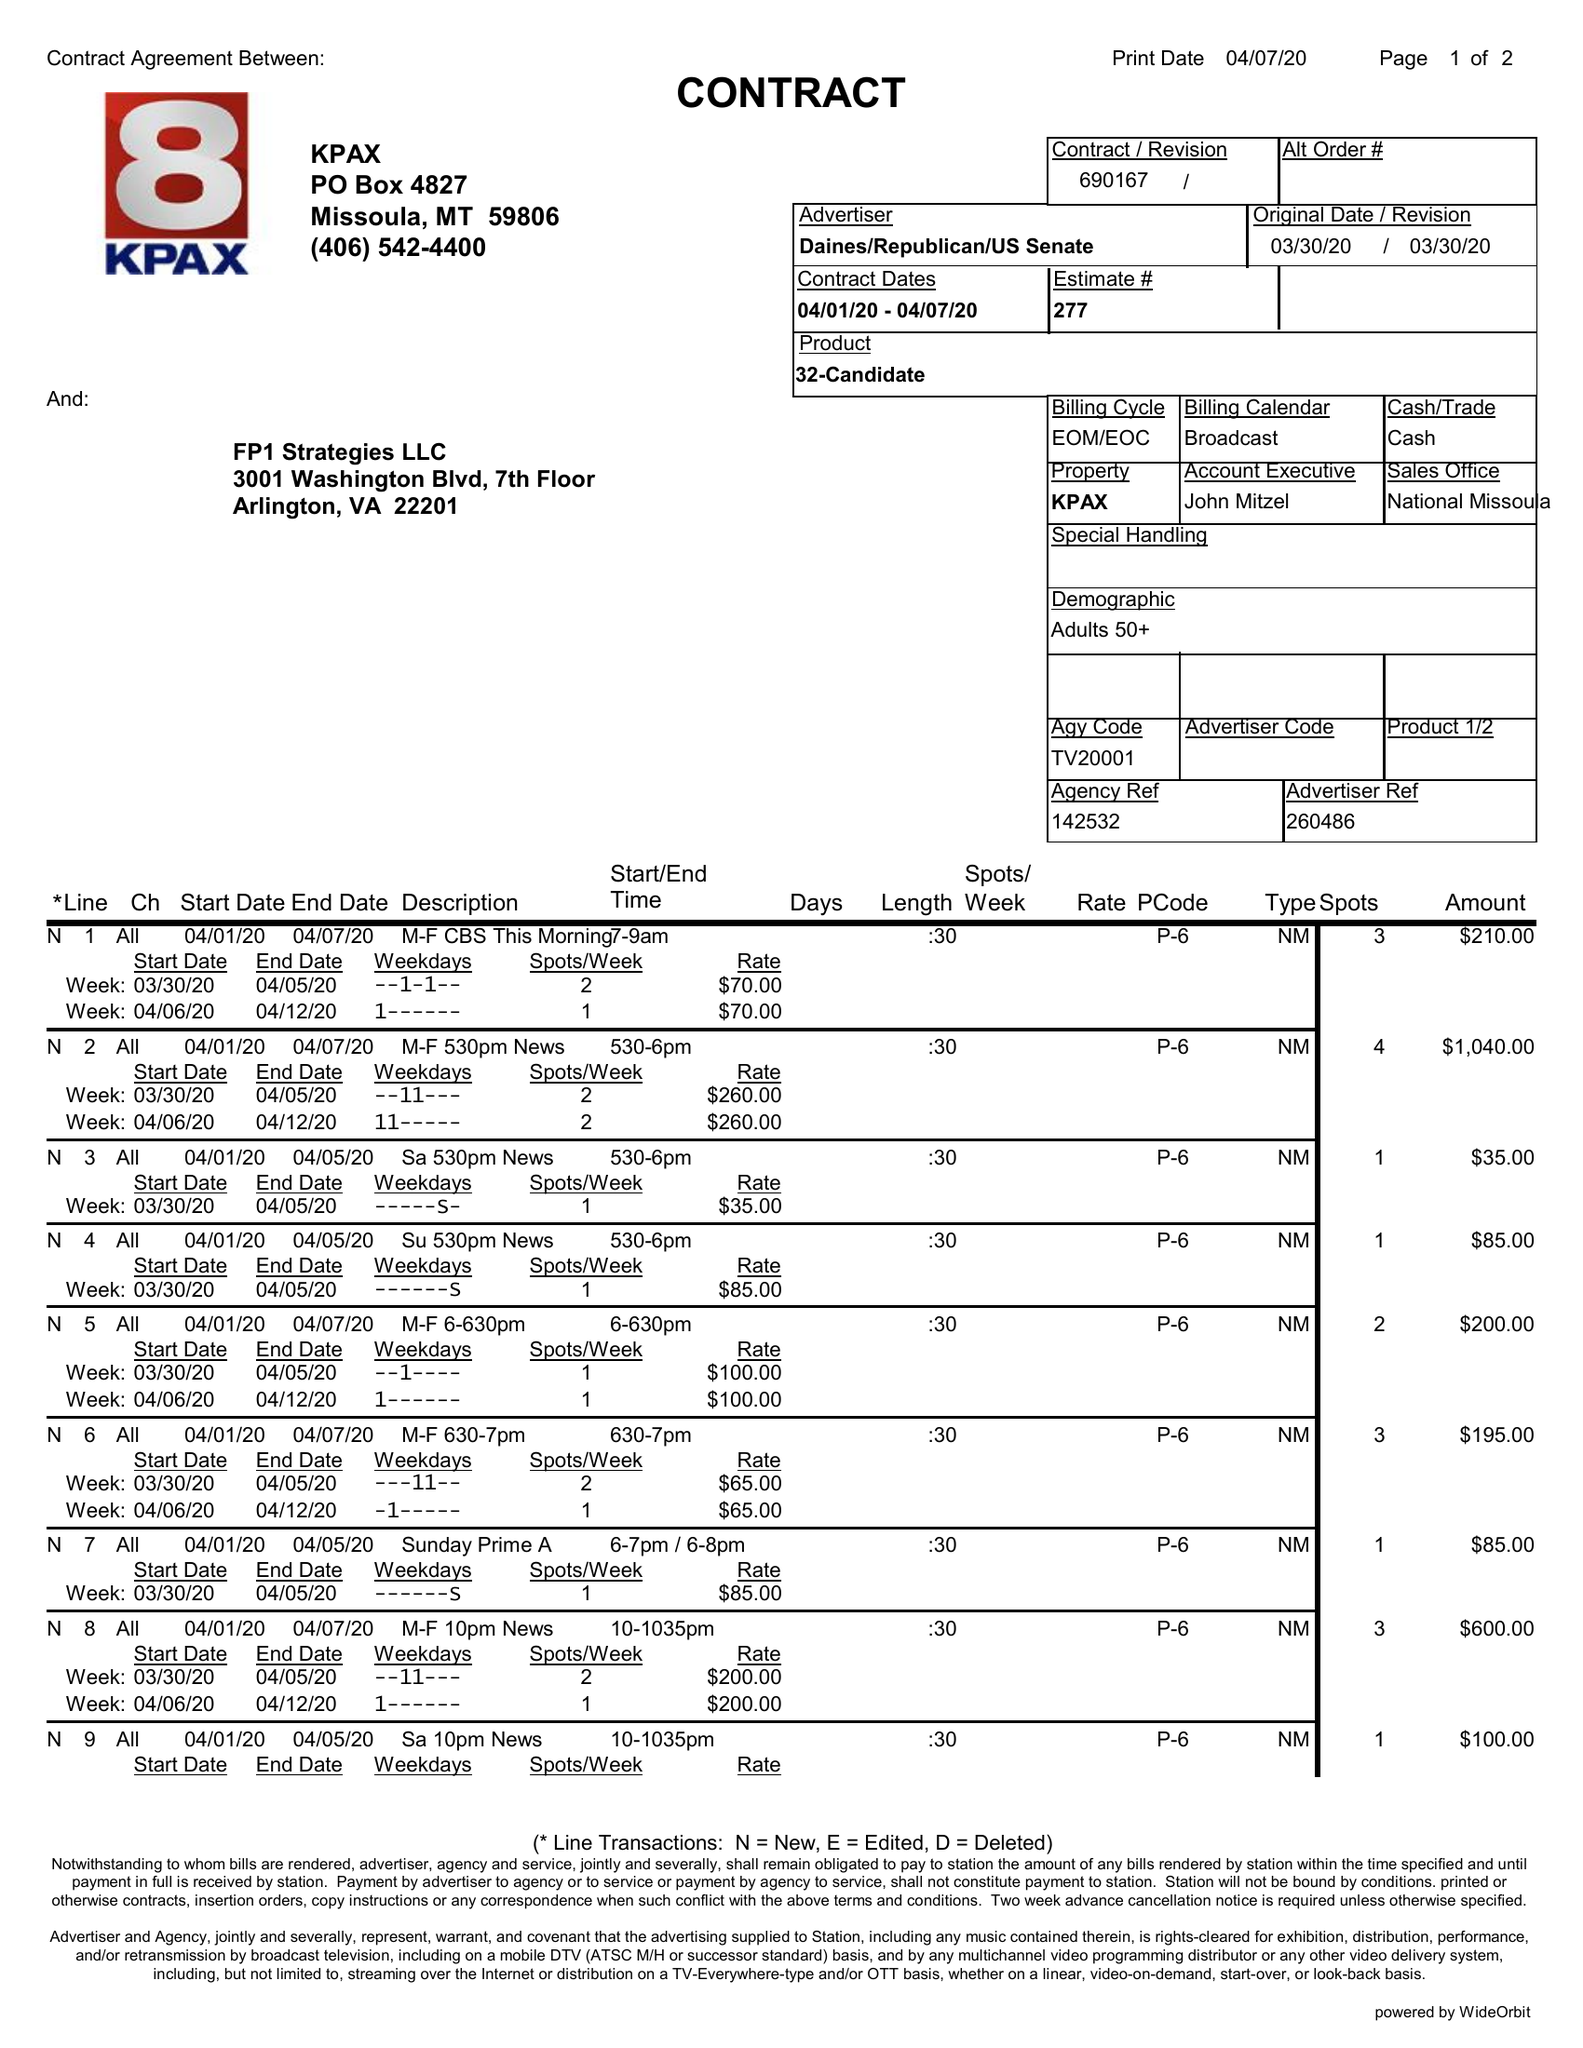What is the value for the advertiser?
Answer the question using a single word or phrase. DAINES/REPUBLICAN/USSENATE 